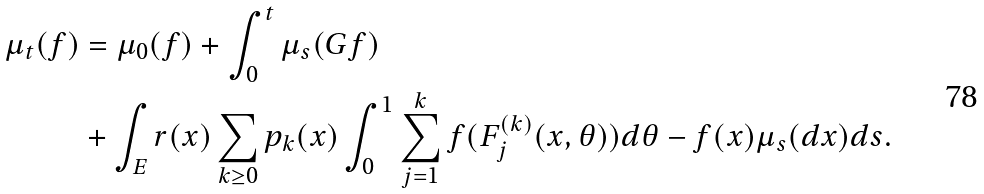<formula> <loc_0><loc_0><loc_500><loc_500>\mu _ { t } ( f ) & = \mu _ { 0 } ( f ) + \int _ { 0 } ^ { t } \mu _ { s } ( G f ) \\ & + \int _ { E } r ( x ) \sum _ { k \geq 0 } p _ { k } ( x ) \int _ { 0 } ^ { 1 } \sum _ { j = 1 } ^ { k } f ( F ^ { ( k ) } _ { j } ( x , \theta ) ) d \theta - f ( x ) \mu _ { s } ( d x ) d s .</formula> 